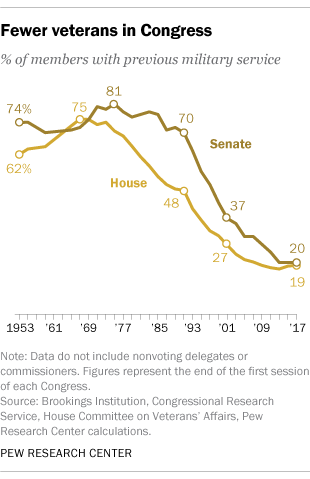Mention a couple of crucial points in this snapshot. The line that reaches the highest point is the brown line. 